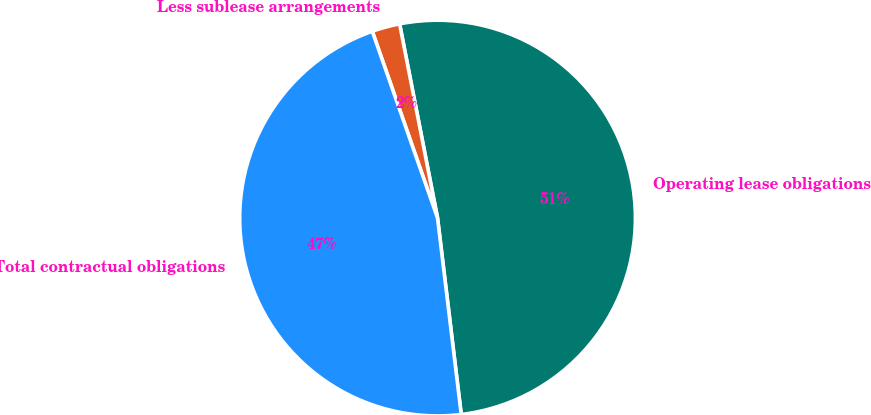Convert chart. <chart><loc_0><loc_0><loc_500><loc_500><pie_chart><fcel>Operating lease obligations<fcel>Less sublease arrangements<fcel>Total contractual obligations<nl><fcel>51.16%<fcel>2.28%<fcel>46.56%<nl></chart> 